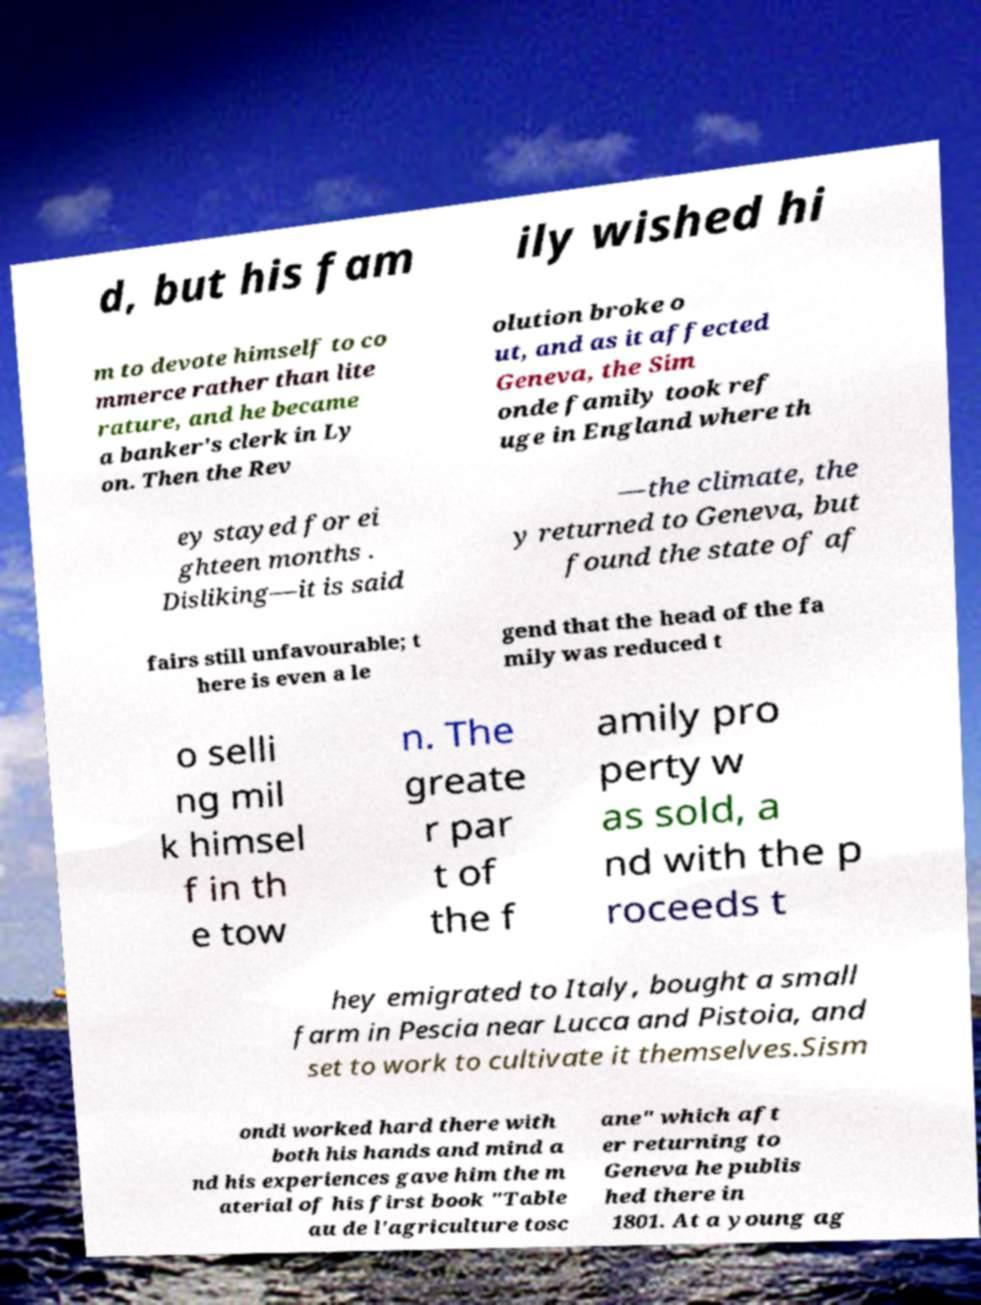There's text embedded in this image that I need extracted. Can you transcribe it verbatim? d, but his fam ily wished hi m to devote himself to co mmerce rather than lite rature, and he became a banker's clerk in Ly on. Then the Rev olution broke o ut, and as it affected Geneva, the Sim onde family took ref uge in England where th ey stayed for ei ghteen months . Disliking—it is said —the climate, the y returned to Geneva, but found the state of af fairs still unfavourable; t here is even a le gend that the head of the fa mily was reduced t o selli ng mil k himsel f in th e tow n. The greate r par t of the f amily pro perty w as sold, a nd with the p roceeds t hey emigrated to Italy, bought a small farm in Pescia near Lucca and Pistoia, and set to work to cultivate it themselves.Sism ondi worked hard there with both his hands and mind a nd his experiences gave him the m aterial of his first book "Table au de l'agriculture tosc ane" which aft er returning to Geneva he publis hed there in 1801. At a young ag 